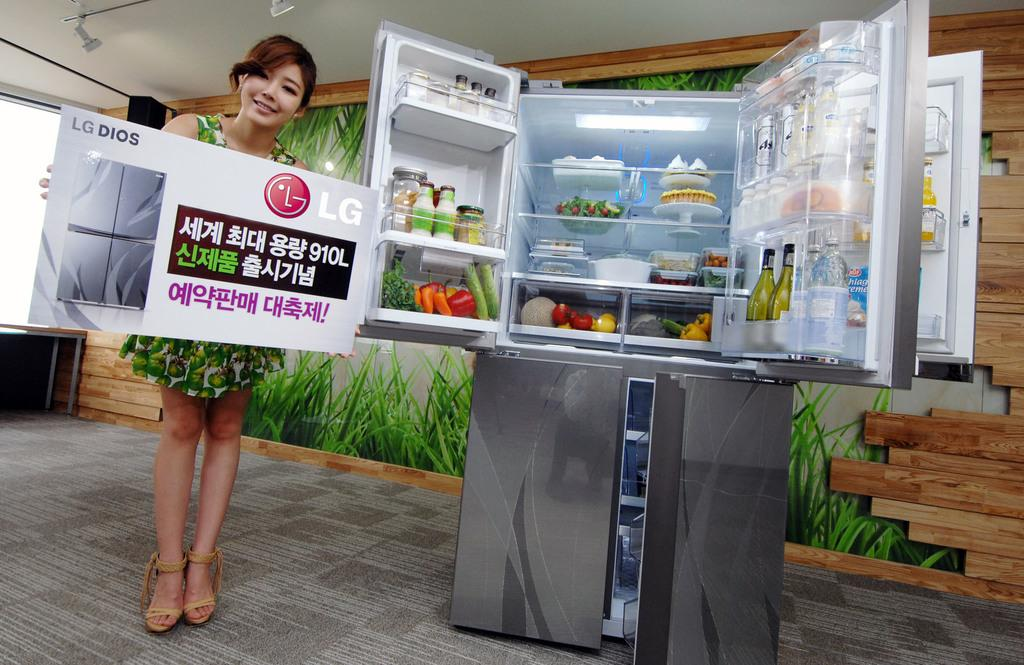<image>
Provide a brief description of the given image. LG Dios is shown on an advert in front of the fridge. 